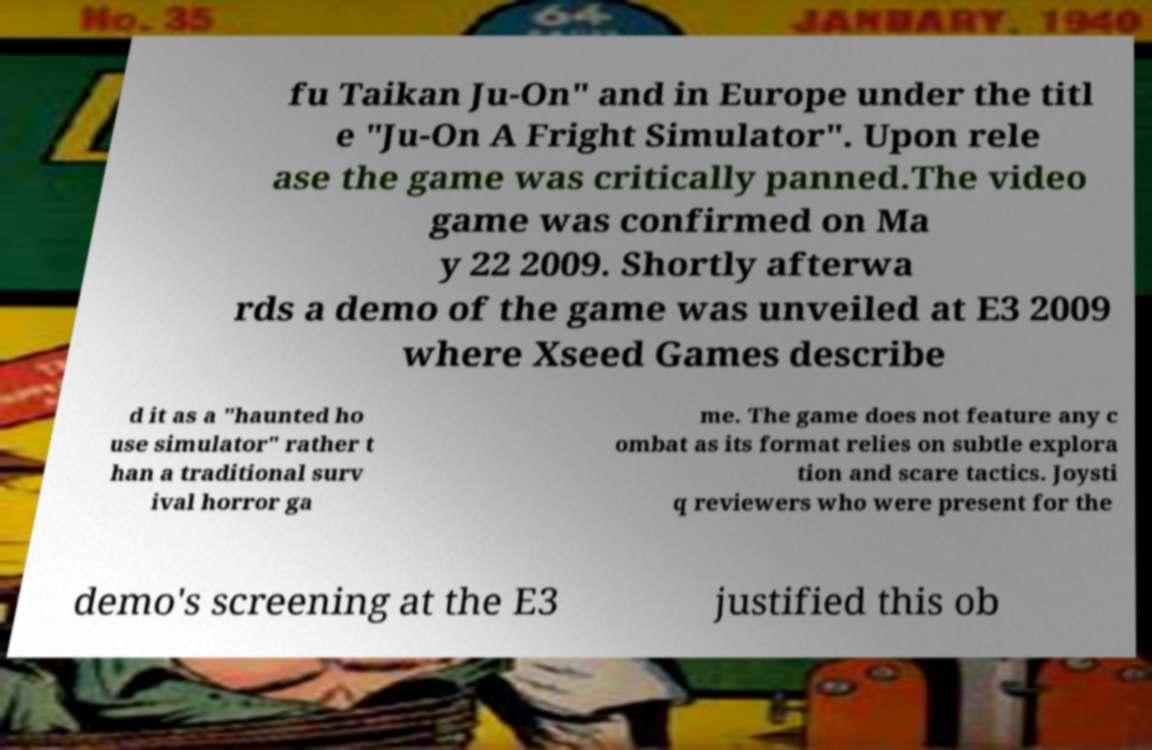Can you accurately transcribe the text from the provided image for me? fu Taikan Ju-On" and in Europe under the titl e "Ju-On A Fright Simulator". Upon rele ase the game was critically panned.The video game was confirmed on Ma y 22 2009. Shortly afterwa rds a demo of the game was unveiled at E3 2009 where Xseed Games describe d it as a "haunted ho use simulator" rather t han a traditional surv ival horror ga me. The game does not feature any c ombat as its format relies on subtle explora tion and scare tactics. Joysti q reviewers who were present for the demo's screening at the E3 justified this ob 